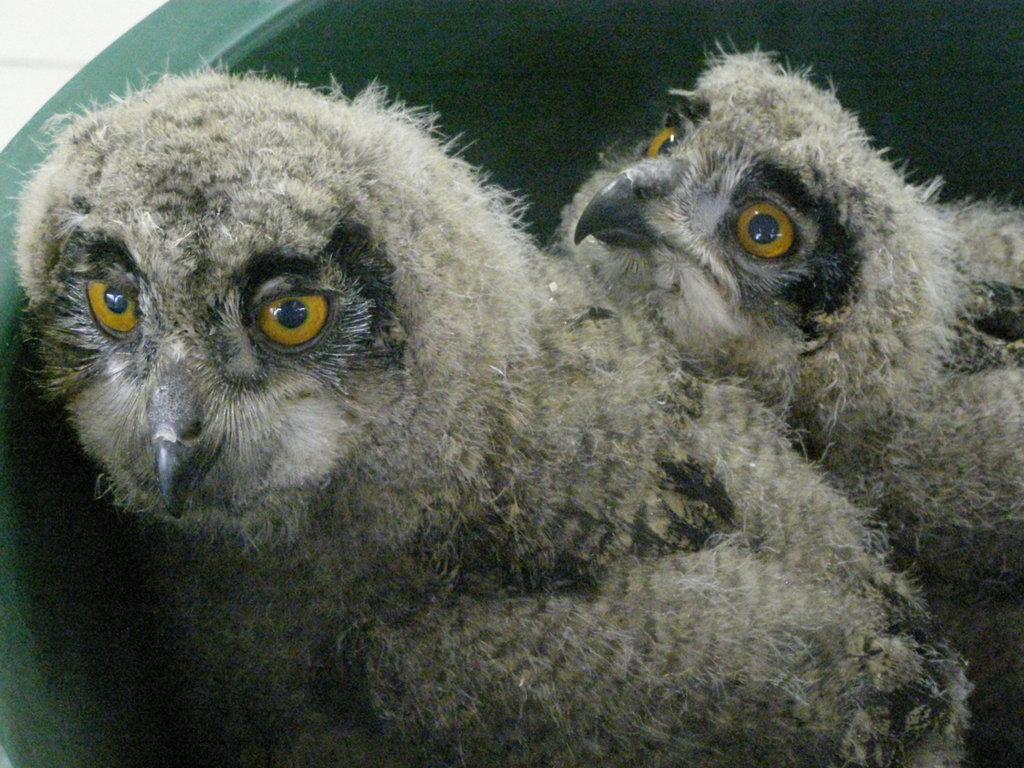Can you describe this image briefly? This picture shows a couple of owls in the plastic tub. 